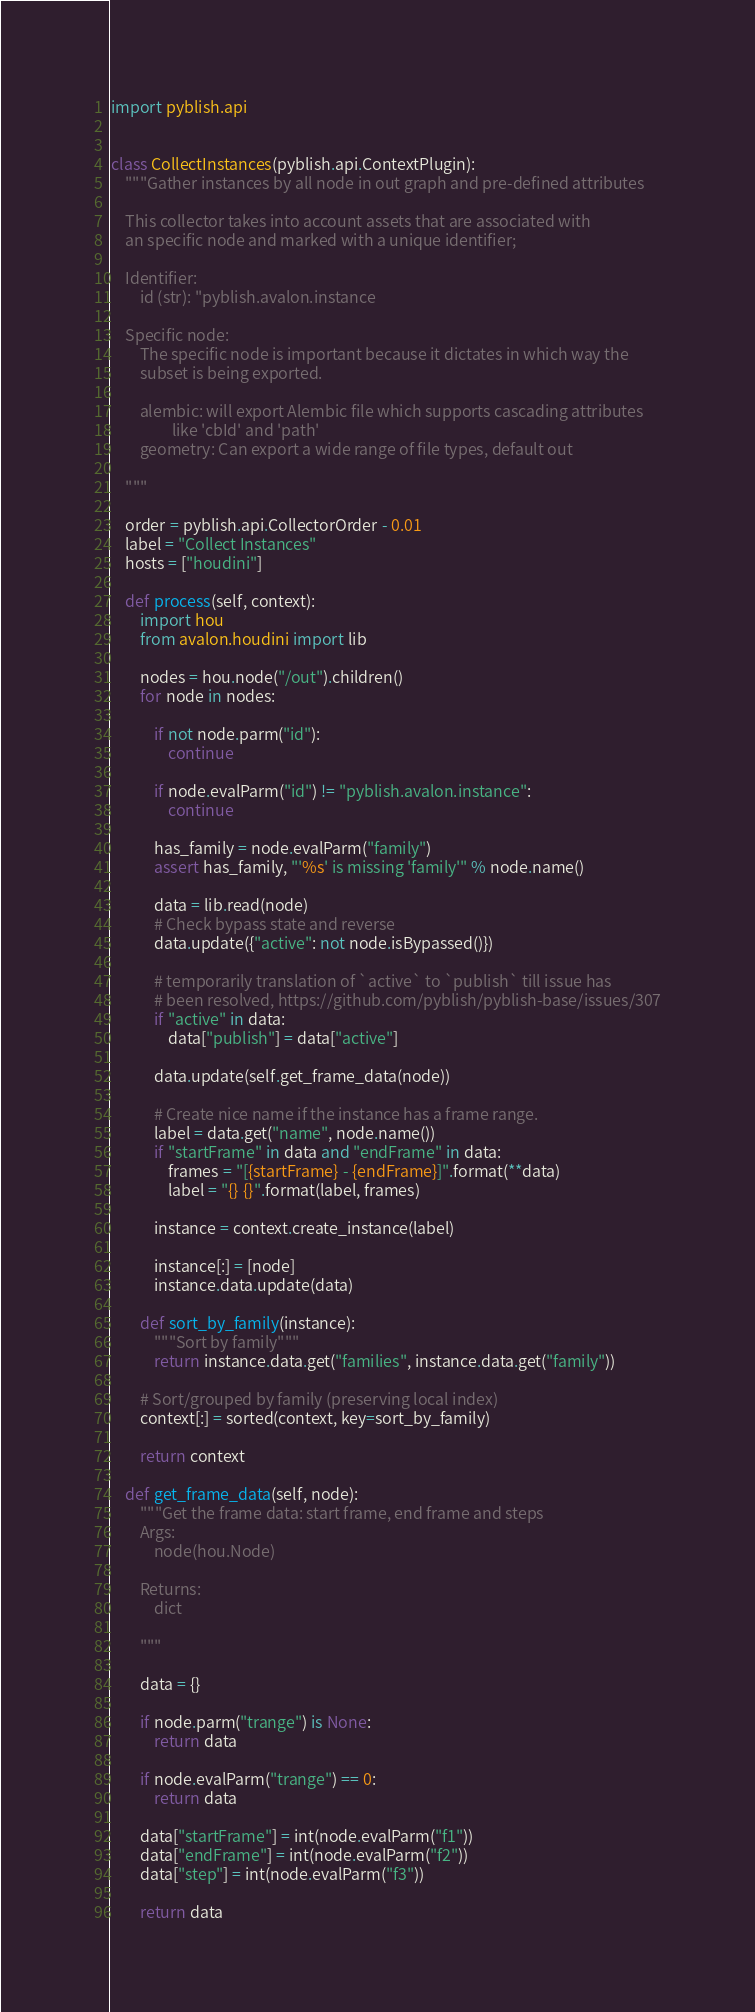Convert code to text. <code><loc_0><loc_0><loc_500><loc_500><_Python_>
import pyblish.api


class CollectInstances(pyblish.api.ContextPlugin):
    """Gather instances by all node in out graph and pre-defined attributes

    This collector takes into account assets that are associated with
    an specific node and marked with a unique identifier;

    Identifier:
        id (str): "pyblish.avalon.instance

    Specific node:
        The specific node is important because it dictates in which way the
        subset is being exported.

        alembic: will export Alembic file which supports cascading attributes
                 like 'cbId' and 'path'
        geometry: Can export a wide range of file types, default out

    """

    order = pyblish.api.CollectorOrder - 0.01
    label = "Collect Instances"
    hosts = ["houdini"]

    def process(self, context):
        import hou
        from avalon.houdini import lib

        nodes = hou.node("/out").children()
        for node in nodes:

            if not node.parm("id"):
                continue

            if node.evalParm("id") != "pyblish.avalon.instance":
                continue

            has_family = node.evalParm("family")
            assert has_family, "'%s' is missing 'family'" % node.name()

            data = lib.read(node)
            # Check bypass state and reverse
            data.update({"active": not node.isBypassed()})

            # temporarily translation of `active` to `publish` till issue has
            # been resolved, https://github.com/pyblish/pyblish-base/issues/307
            if "active" in data:
                data["publish"] = data["active"]

            data.update(self.get_frame_data(node))

            # Create nice name if the instance has a frame range.
            label = data.get("name", node.name())
            if "startFrame" in data and "endFrame" in data:
                frames = "[{startFrame} - {endFrame}]".format(**data)
                label = "{} {}".format(label, frames)

            instance = context.create_instance(label)

            instance[:] = [node]
            instance.data.update(data)

        def sort_by_family(instance):
            """Sort by family"""
            return instance.data.get("families", instance.data.get("family"))

        # Sort/grouped by family (preserving local index)
        context[:] = sorted(context, key=sort_by_family)

        return context

    def get_frame_data(self, node):
        """Get the frame data: start frame, end frame and steps
        Args:
            node(hou.Node)

        Returns:
            dict

        """

        data = {}

        if node.parm("trange") is None:
            return data

        if node.evalParm("trange") == 0:
            return data

        data["startFrame"] = int(node.evalParm("f1"))
        data["endFrame"] = int(node.evalParm("f2"))
        data["step"] = int(node.evalParm("f3"))

        return data
</code> 